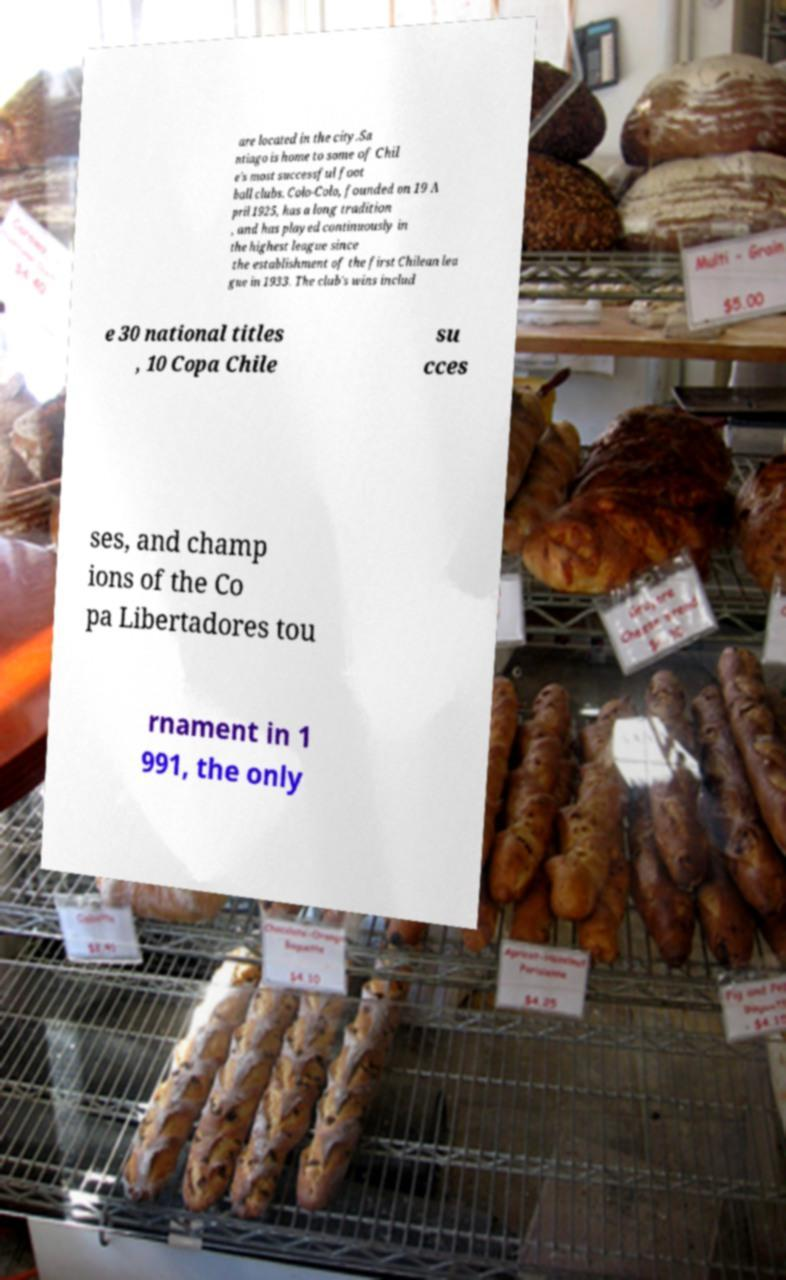Please identify and transcribe the text found in this image. are located in the city.Sa ntiago is home to some of Chil e's most successful foot ball clubs. Colo-Colo, founded on 19 A pril 1925, has a long tradition , and has played continuously in the highest league since the establishment of the first Chilean lea gue in 1933. The club's wins includ e 30 national titles , 10 Copa Chile su cces ses, and champ ions of the Co pa Libertadores tou rnament in 1 991, the only 